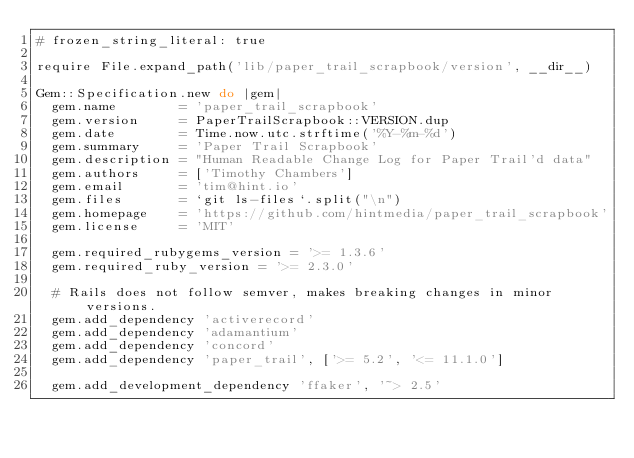Convert code to text. <code><loc_0><loc_0><loc_500><loc_500><_Ruby_># frozen_string_literal: true

require File.expand_path('lib/paper_trail_scrapbook/version', __dir__)

Gem::Specification.new do |gem|
  gem.name        = 'paper_trail_scrapbook'
  gem.version     = PaperTrailScrapbook::VERSION.dup
  gem.date        = Time.now.utc.strftime('%Y-%m-%d')
  gem.summary     = 'Paper Trail Scrapbook'
  gem.description = "Human Readable Change Log for Paper Trail'd data"
  gem.authors     = ['Timothy Chambers']
  gem.email       = 'tim@hint.io'
  gem.files       = `git ls-files`.split("\n")
  gem.homepage    = 'https://github.com/hintmedia/paper_trail_scrapbook'
  gem.license     = 'MIT'

  gem.required_rubygems_version = '>= 1.3.6'
  gem.required_ruby_version = '>= 2.3.0'

  # Rails does not follow semver, makes breaking changes in minor versions.
  gem.add_dependency 'activerecord'
  gem.add_dependency 'adamantium'
  gem.add_dependency 'concord'
  gem.add_dependency 'paper_trail', ['>= 5.2', '<= 11.1.0']

  gem.add_development_dependency 'ffaker', '~> 2.5'</code> 